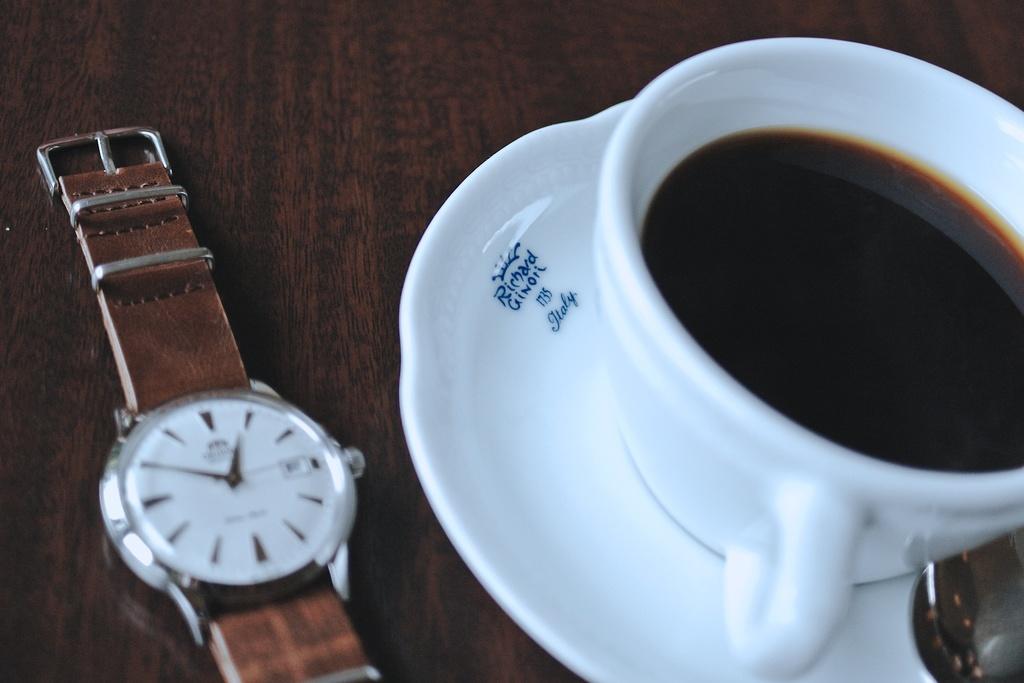Were the cup and plate made in 1735?
Your response must be concise. Yes. This is caffe and watch?
Your answer should be compact. Yes. 